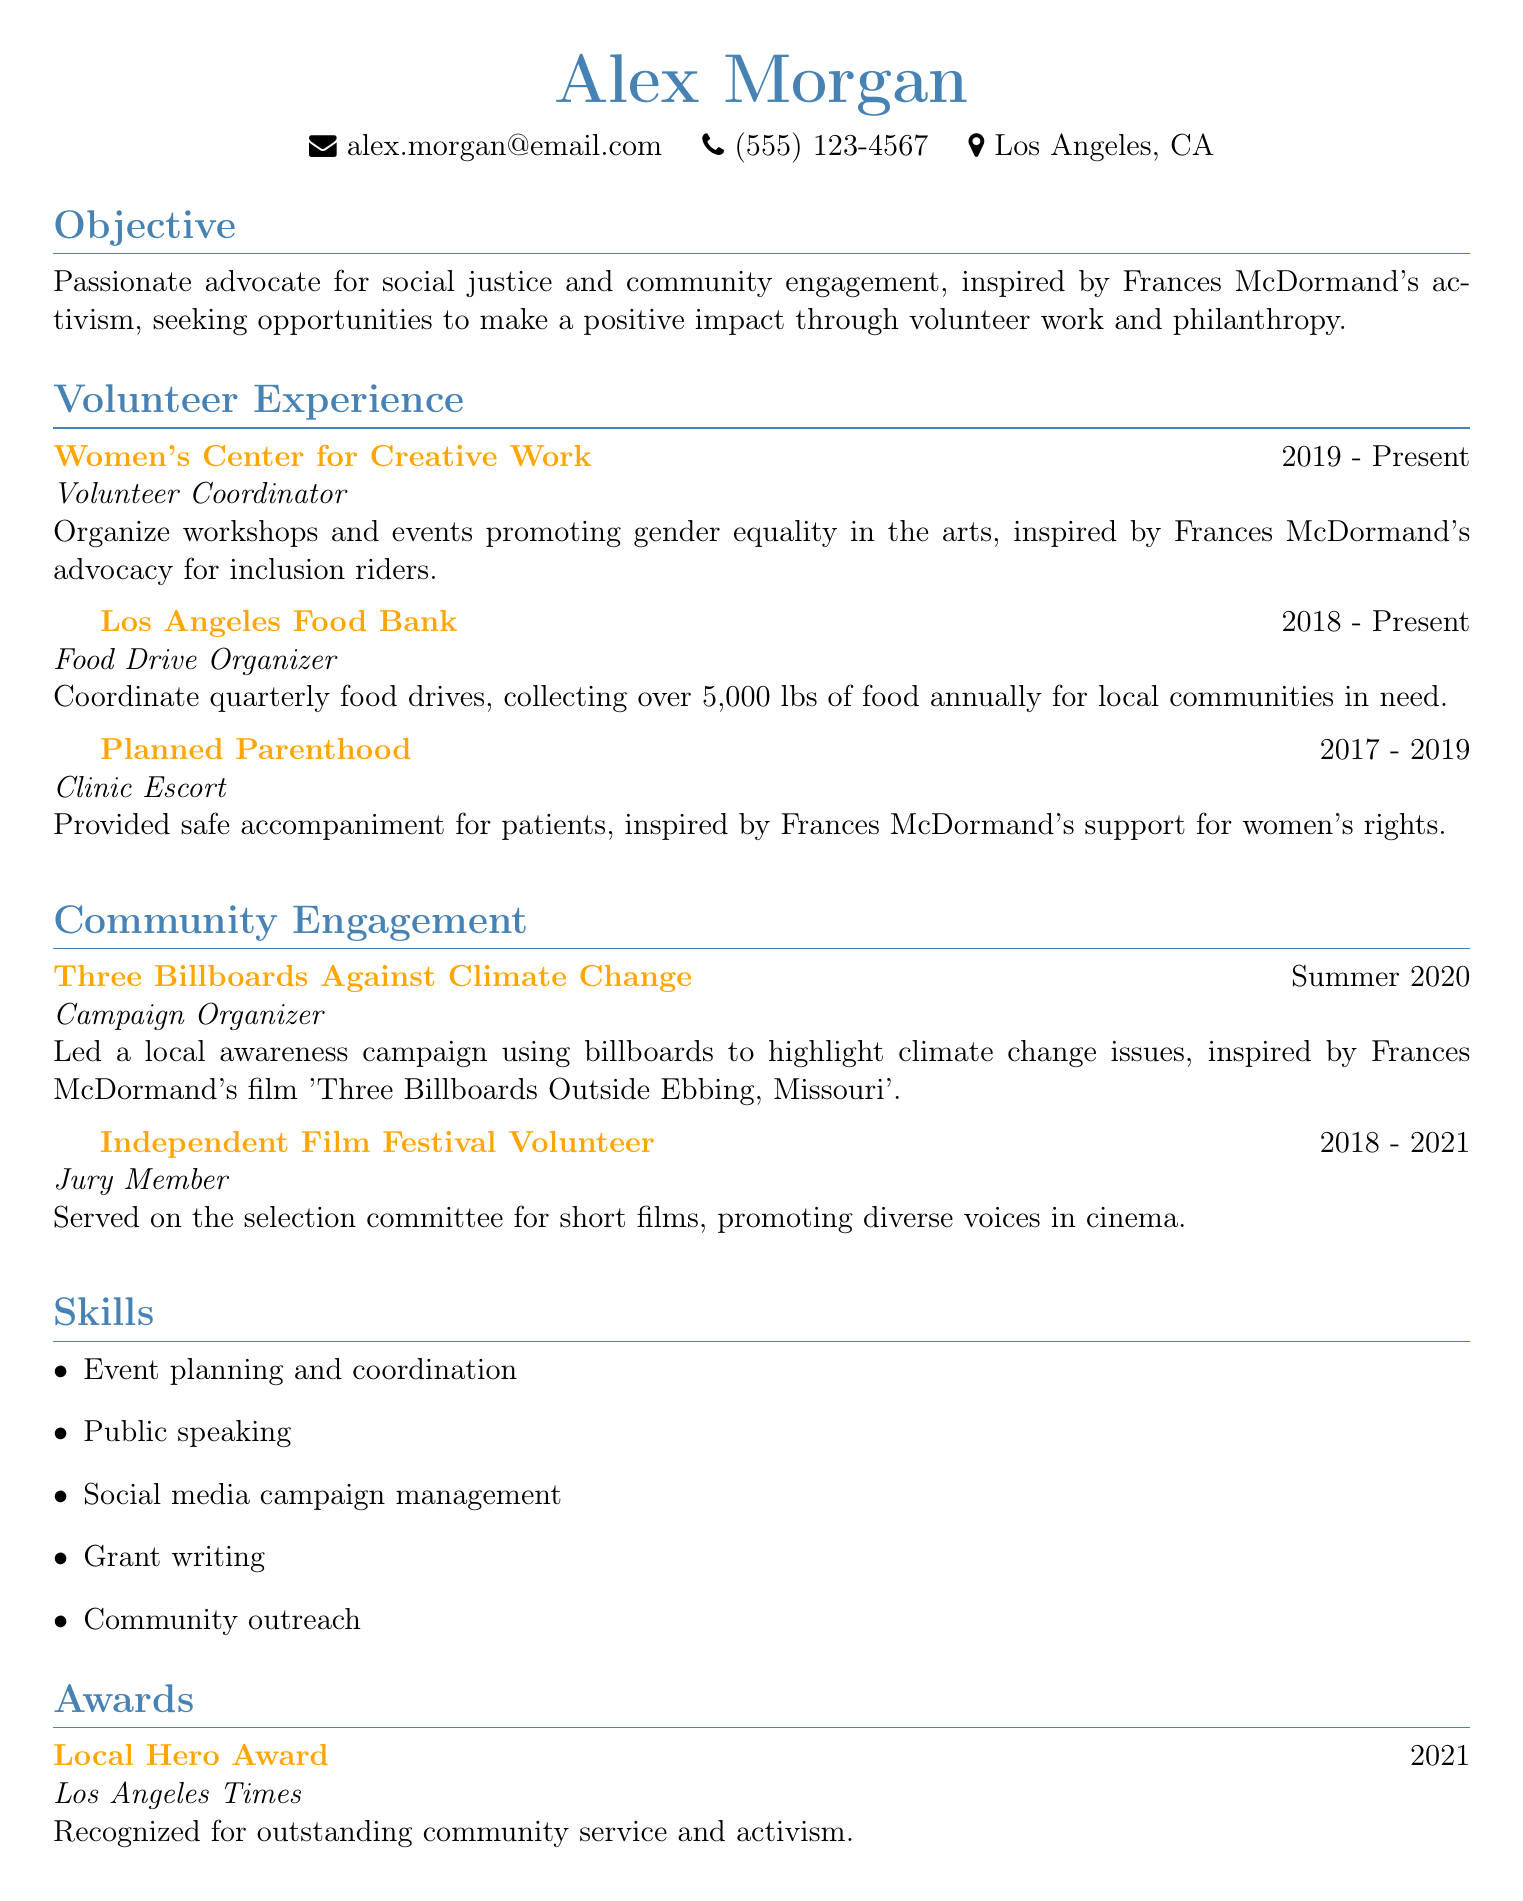What is the name of the individual in the CV? The name of the individual is presented at the top of the document.
Answer: Alex Morgan What is the email address listed in the CV? The email address is clearly indicated under personal information.
Answer: alex.morgan@email.com How long has Alex Morgan been a Volunteer Coordinator at the Women's Center for Creative Work? The duration of this role is specified in the volunteer experience section.
Answer: 2019 - Present Which award did Alex Morgan receive in 2021? The award is mentioned in the awards section of the CV.
Answer: Local Hero Award What was the role of Alex Morgan in the "Three Billboards Against Climate Change" project? The role is defined in the community engagement section of the CV.
Answer: Campaign Organizer What community engagement role did Alex Morgan fulfill between 2018 and 2021? This role is specified within the community engagement section of the CV.
Answer: Jury Member How many pounds of food does Alex Morgan collect annually for the Los Angeles Food Bank? The quantity is specified in the description of the volunteer experience.
Answer: 5,000 lbs What skill is related to public speaking in Alex Morgan's CV? The skills section lists this particular skill.
Answer: Public speaking What organization recognized Alex Morgan for outstanding community service? This information is found within the awards section of the CV.
Answer: Los Angeles Times 